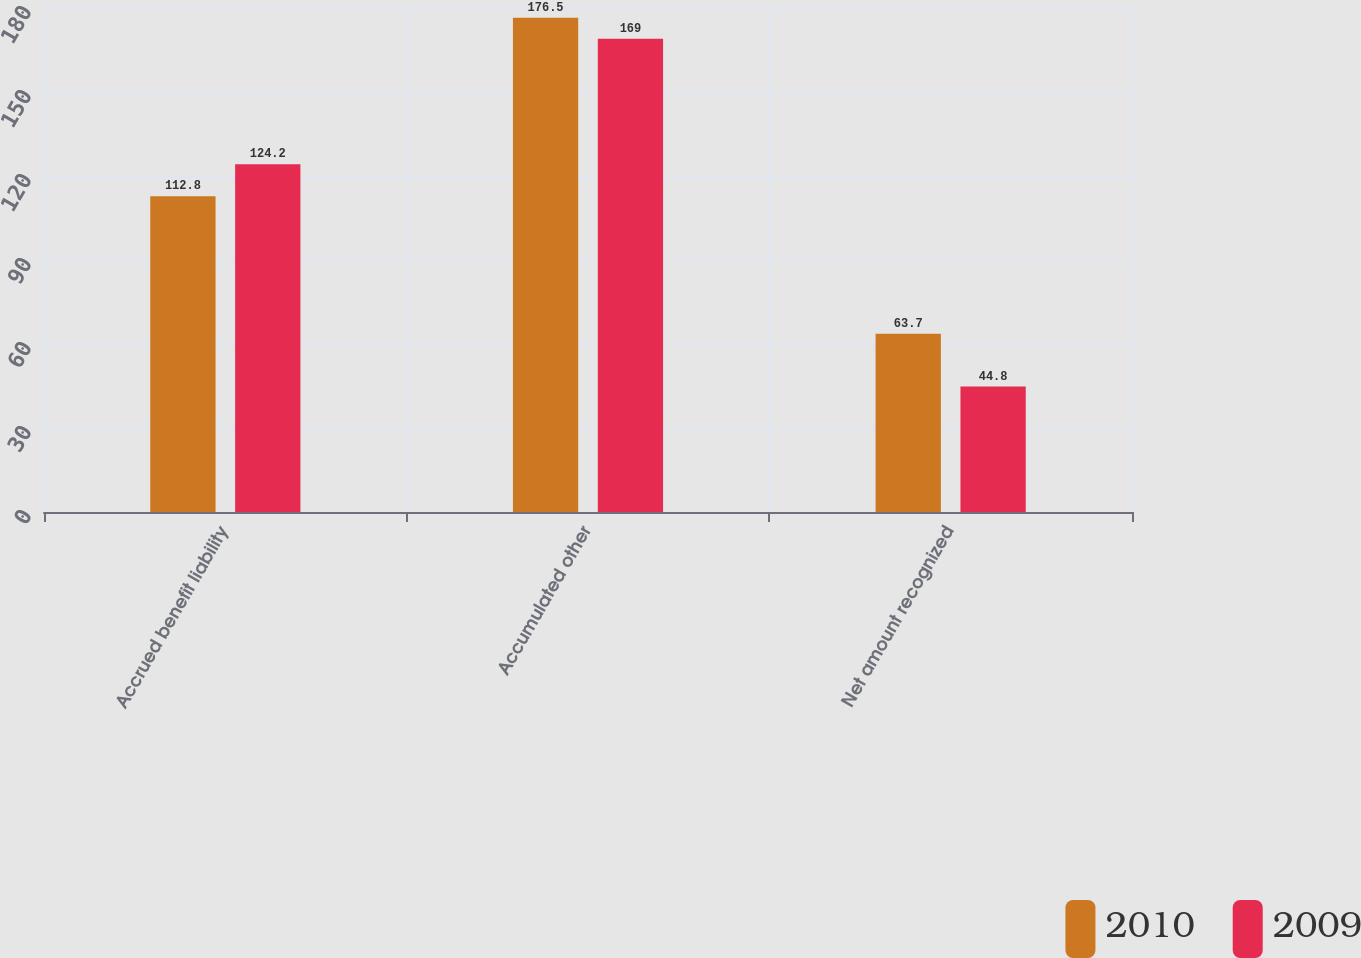Convert chart. <chart><loc_0><loc_0><loc_500><loc_500><stacked_bar_chart><ecel><fcel>Accrued benefit liability<fcel>Accumulated other<fcel>Net amount recognized<nl><fcel>2010<fcel>112.8<fcel>176.5<fcel>63.7<nl><fcel>2009<fcel>124.2<fcel>169<fcel>44.8<nl></chart> 